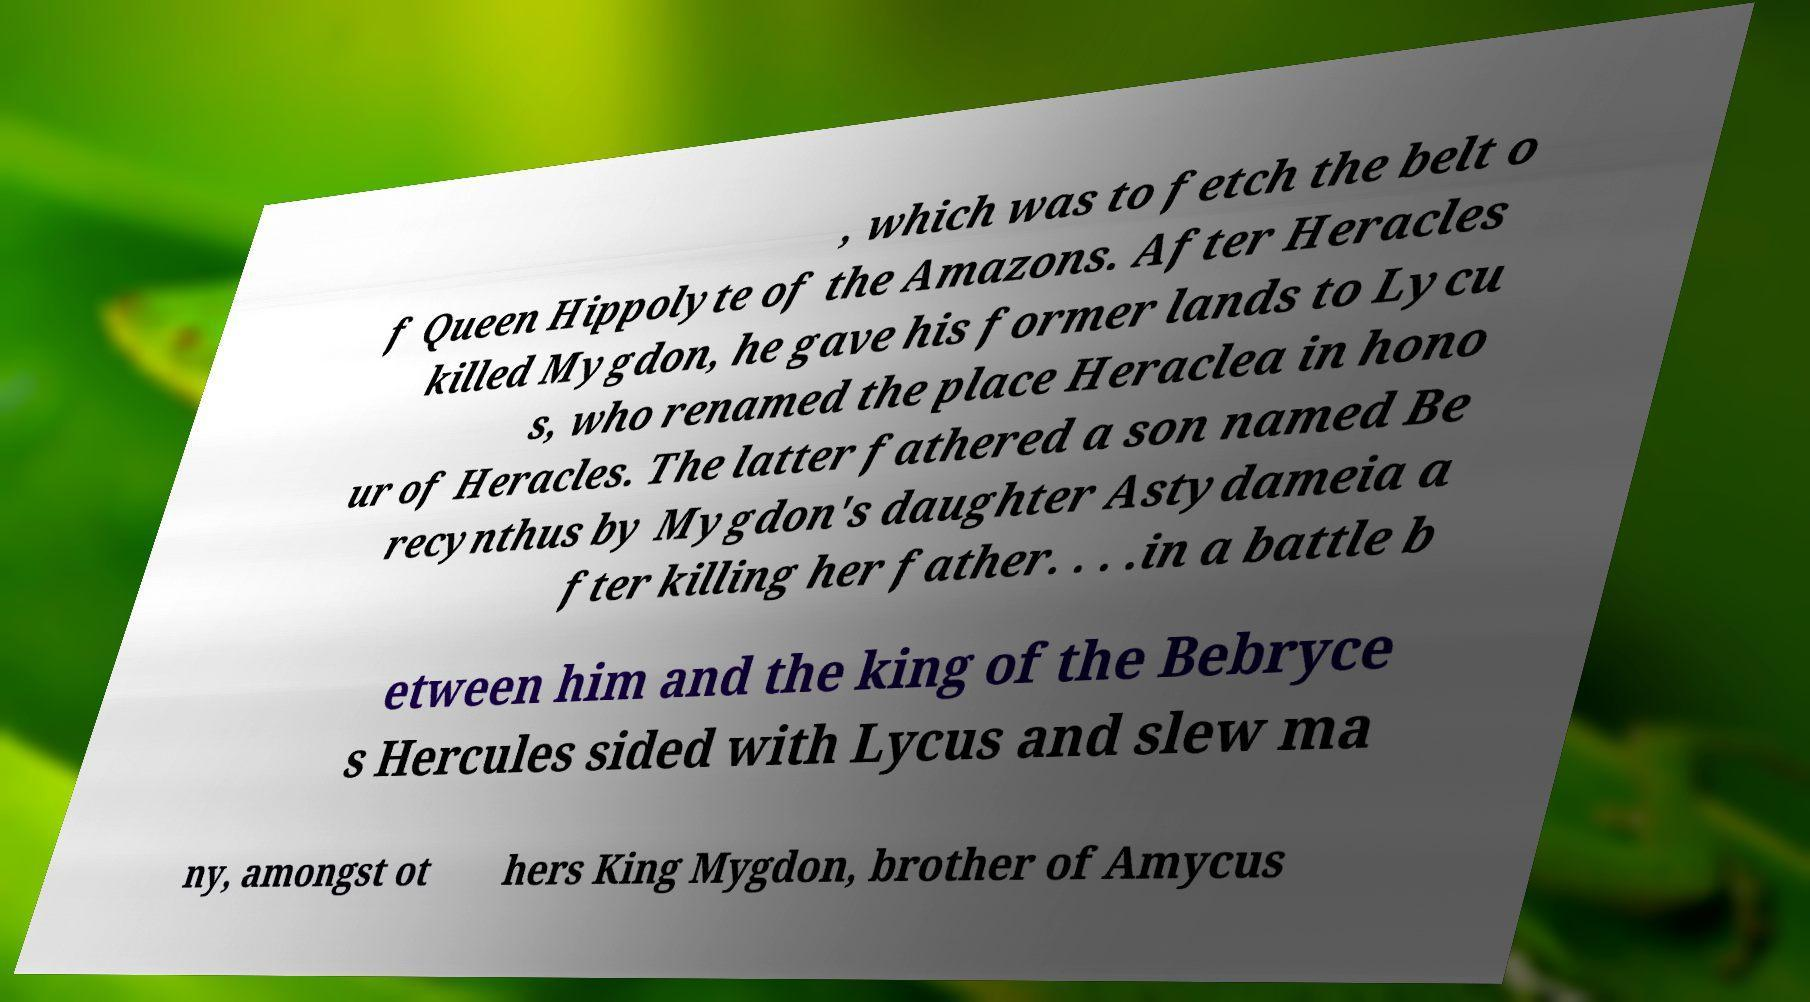Please identify and transcribe the text found in this image. , which was to fetch the belt o f Queen Hippolyte of the Amazons. After Heracles killed Mygdon, he gave his former lands to Lycu s, who renamed the place Heraclea in hono ur of Heracles. The latter fathered a son named Be recynthus by Mygdon's daughter Astydameia a fter killing her father. . . .in a battle b etween him and the king of the Bebryce s Hercules sided with Lycus and slew ma ny, amongst ot hers King Mygdon, brother of Amycus 